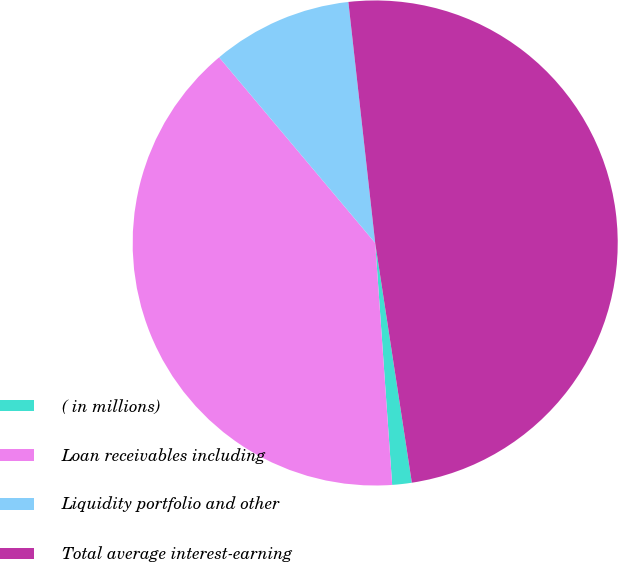<chart> <loc_0><loc_0><loc_500><loc_500><pie_chart><fcel>( in millions)<fcel>Loan receivables including<fcel>Liquidity portfolio and other<fcel>Total average interest-earning<nl><fcel>1.3%<fcel>39.99%<fcel>9.36%<fcel>49.35%<nl></chart> 